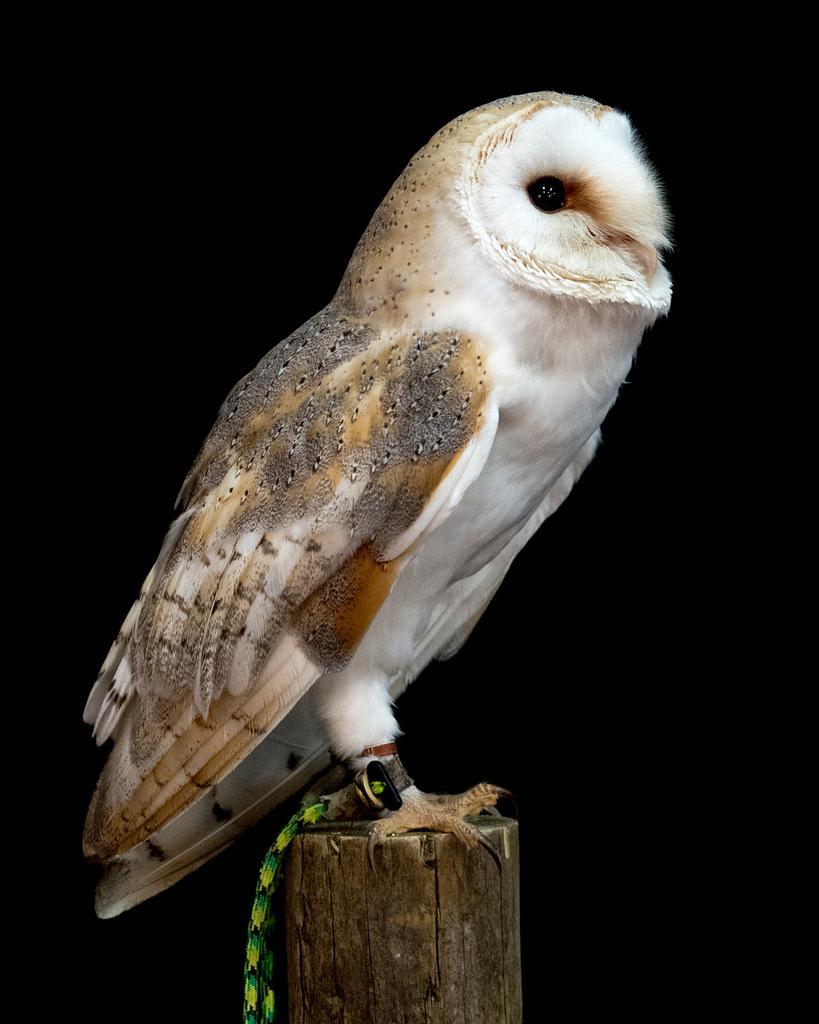Describe this image in one or two sentences. In the center of the image, we can see a bird on the trunk and the background is in black color. 